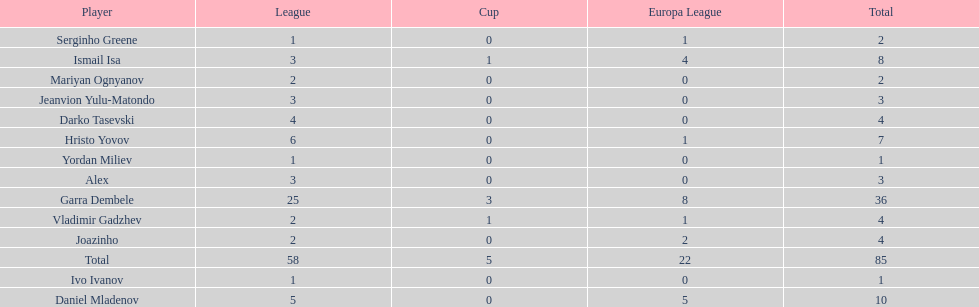Who was the top goalscorer on this team? Garra Dembele. 